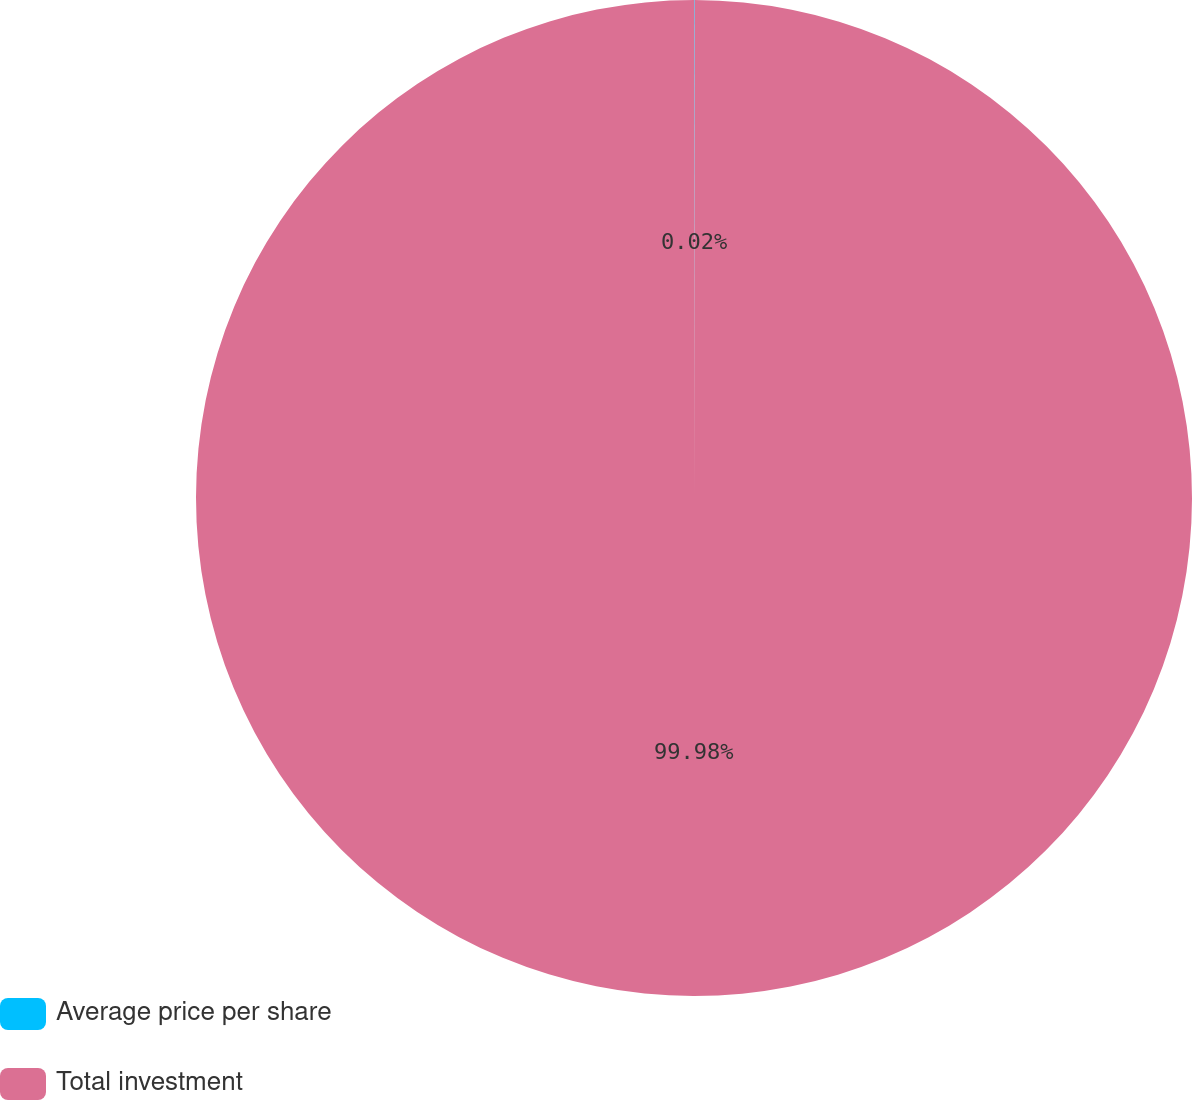Convert chart. <chart><loc_0><loc_0><loc_500><loc_500><pie_chart><fcel>Average price per share<fcel>Total investment<nl><fcel>0.02%<fcel>99.98%<nl></chart> 